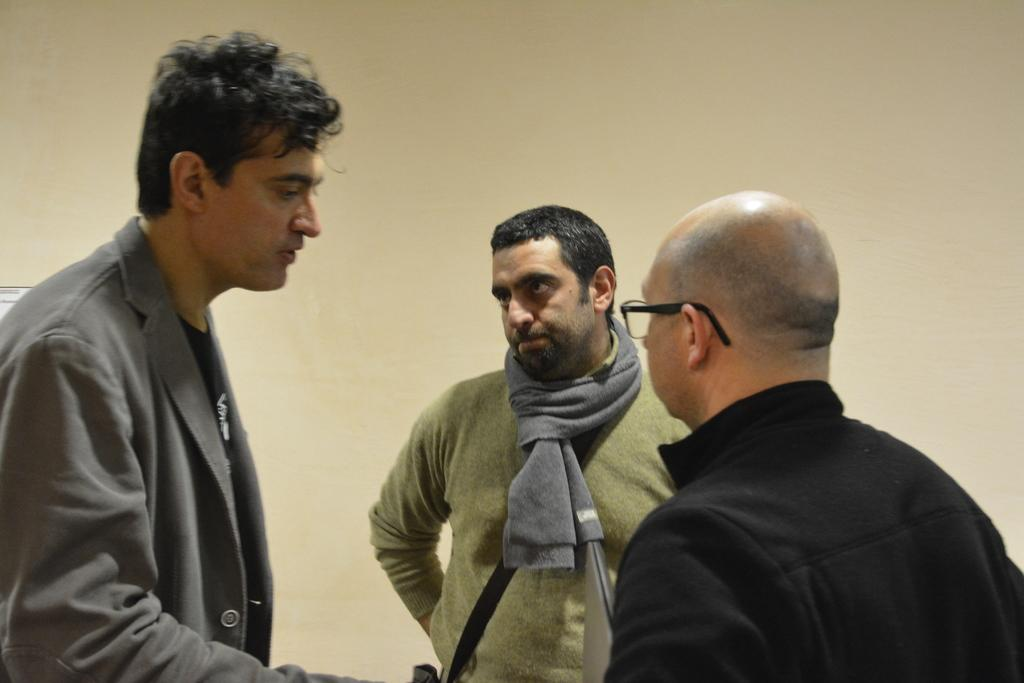What is present in the image? There are people standing in the image. What can be seen in the background of the image? There is a wall visible in the background of the image. What type of tank can be seen in the image? There is no tank present in the image; it only features people standing and a wall in the background. 